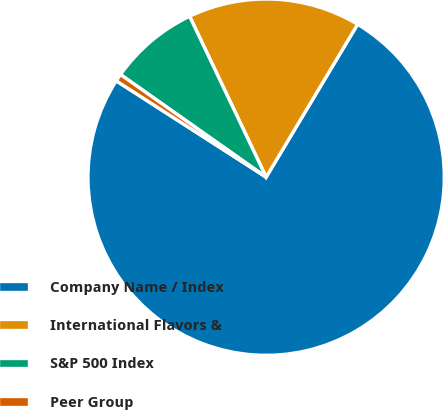<chart> <loc_0><loc_0><loc_500><loc_500><pie_chart><fcel>Company Name / Index<fcel>International Flavors &<fcel>S&P 500 Index<fcel>Peer Group<nl><fcel>75.51%<fcel>15.65%<fcel>8.16%<fcel>0.68%<nl></chart> 